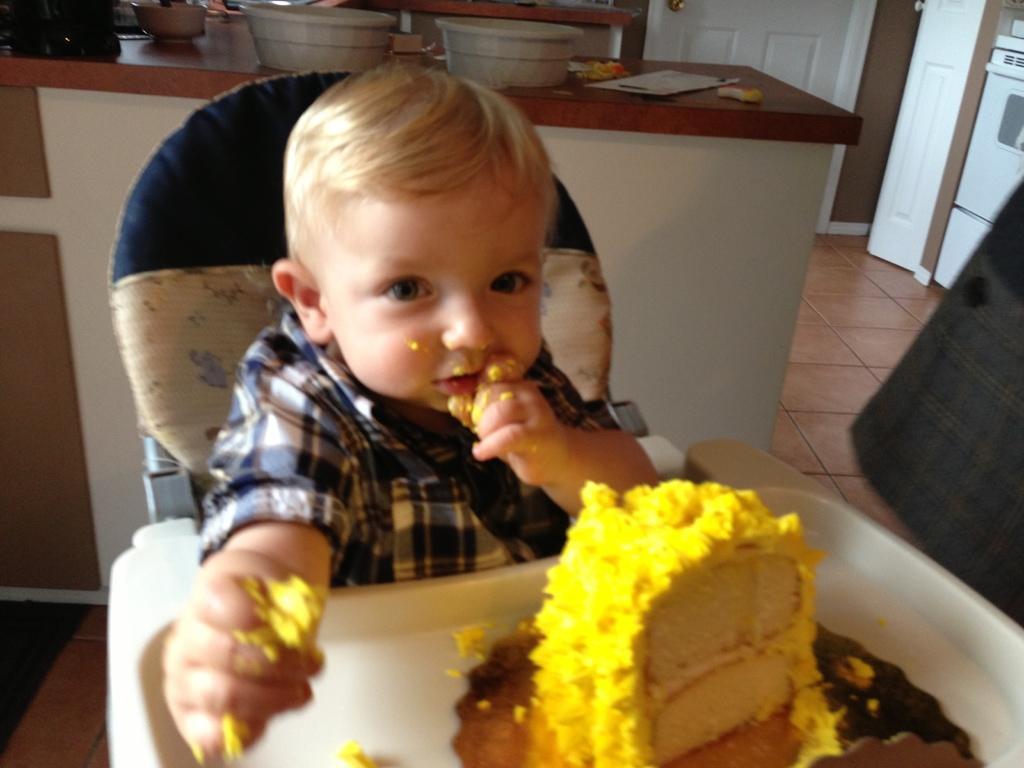How would you summarize this image in a sentence or two? In this picture boy is highlighted. He is sitting on a chair. We can see that in-front of him there is a yellow cake. I think he is eating the cake, as we can see there is a cake on his hand. Backside of him there is a table. Above the table there are 2 containers. There is a card. Door is in white color. Floor with tiles. 